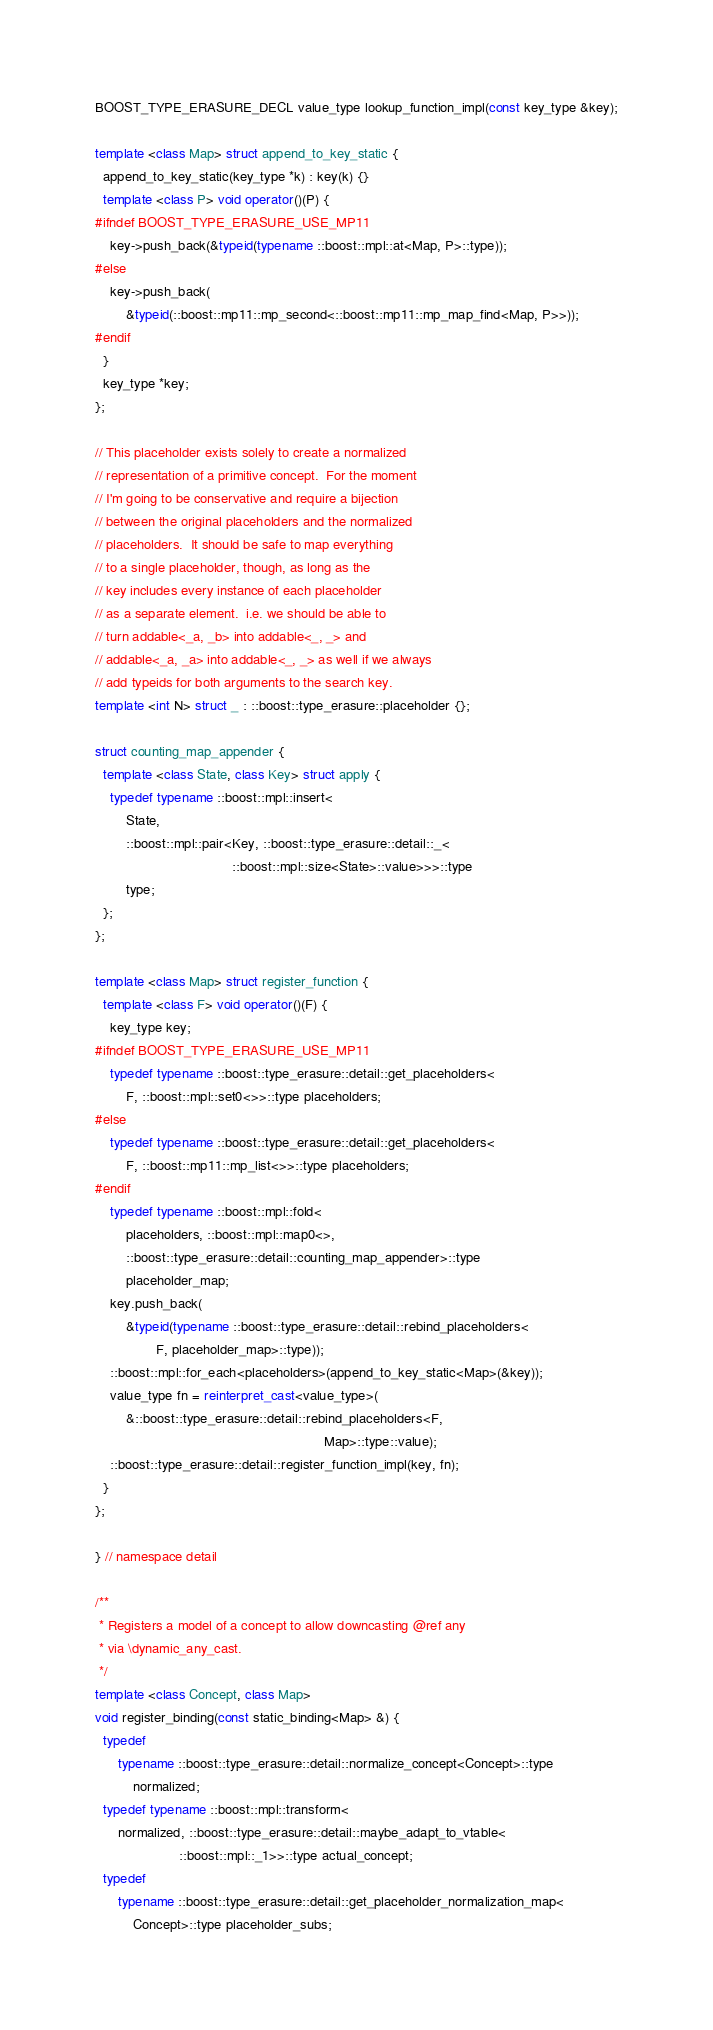Convert code to text. <code><loc_0><loc_0><loc_500><loc_500><_C++_>BOOST_TYPE_ERASURE_DECL value_type lookup_function_impl(const key_type &key);

template <class Map> struct append_to_key_static {
  append_to_key_static(key_type *k) : key(k) {}
  template <class P> void operator()(P) {
#ifndef BOOST_TYPE_ERASURE_USE_MP11
    key->push_back(&typeid(typename ::boost::mpl::at<Map, P>::type));
#else
    key->push_back(
        &typeid(::boost::mp11::mp_second<::boost::mp11::mp_map_find<Map, P>>));
#endif
  }
  key_type *key;
};

// This placeholder exists solely to create a normalized
// representation of a primitive concept.  For the moment
// I'm going to be conservative and require a bijection
// between the original placeholders and the normalized
// placeholders.  It should be safe to map everything
// to a single placeholder, though, as long as the
// key includes every instance of each placeholder
// as a separate element.  i.e. we should be able to
// turn addable<_a, _b> into addable<_, _> and
// addable<_a, _a> into addable<_, _> as well if we always
// add typeids for both arguments to the search key.
template <int N> struct _ : ::boost::type_erasure::placeholder {};

struct counting_map_appender {
  template <class State, class Key> struct apply {
    typedef typename ::boost::mpl::insert<
        State,
        ::boost::mpl::pair<Key, ::boost::type_erasure::detail::_<
                                    ::boost::mpl::size<State>::value>>>::type
        type;
  };
};

template <class Map> struct register_function {
  template <class F> void operator()(F) {
    key_type key;
#ifndef BOOST_TYPE_ERASURE_USE_MP11
    typedef typename ::boost::type_erasure::detail::get_placeholders<
        F, ::boost::mpl::set0<>>::type placeholders;
#else
    typedef typename ::boost::type_erasure::detail::get_placeholders<
        F, ::boost::mp11::mp_list<>>::type placeholders;
#endif
    typedef typename ::boost::mpl::fold<
        placeholders, ::boost::mpl::map0<>,
        ::boost::type_erasure::detail::counting_map_appender>::type
        placeholder_map;
    key.push_back(
        &typeid(typename ::boost::type_erasure::detail::rebind_placeholders<
                F, placeholder_map>::type));
    ::boost::mpl::for_each<placeholders>(append_to_key_static<Map>(&key));
    value_type fn = reinterpret_cast<value_type>(
        &::boost::type_erasure::detail::rebind_placeholders<F,
                                                            Map>::type::value);
    ::boost::type_erasure::detail::register_function_impl(key, fn);
  }
};

} // namespace detail

/**
 * Registers a model of a concept to allow downcasting @ref any
 * via \dynamic_any_cast.
 */
template <class Concept, class Map>
void register_binding(const static_binding<Map> &) {
  typedef
      typename ::boost::type_erasure::detail::normalize_concept<Concept>::type
          normalized;
  typedef typename ::boost::mpl::transform<
      normalized, ::boost::type_erasure::detail::maybe_adapt_to_vtable<
                      ::boost::mpl::_1>>::type actual_concept;
  typedef
      typename ::boost::type_erasure::detail::get_placeholder_normalization_map<
          Concept>::type placeholder_subs;</code> 